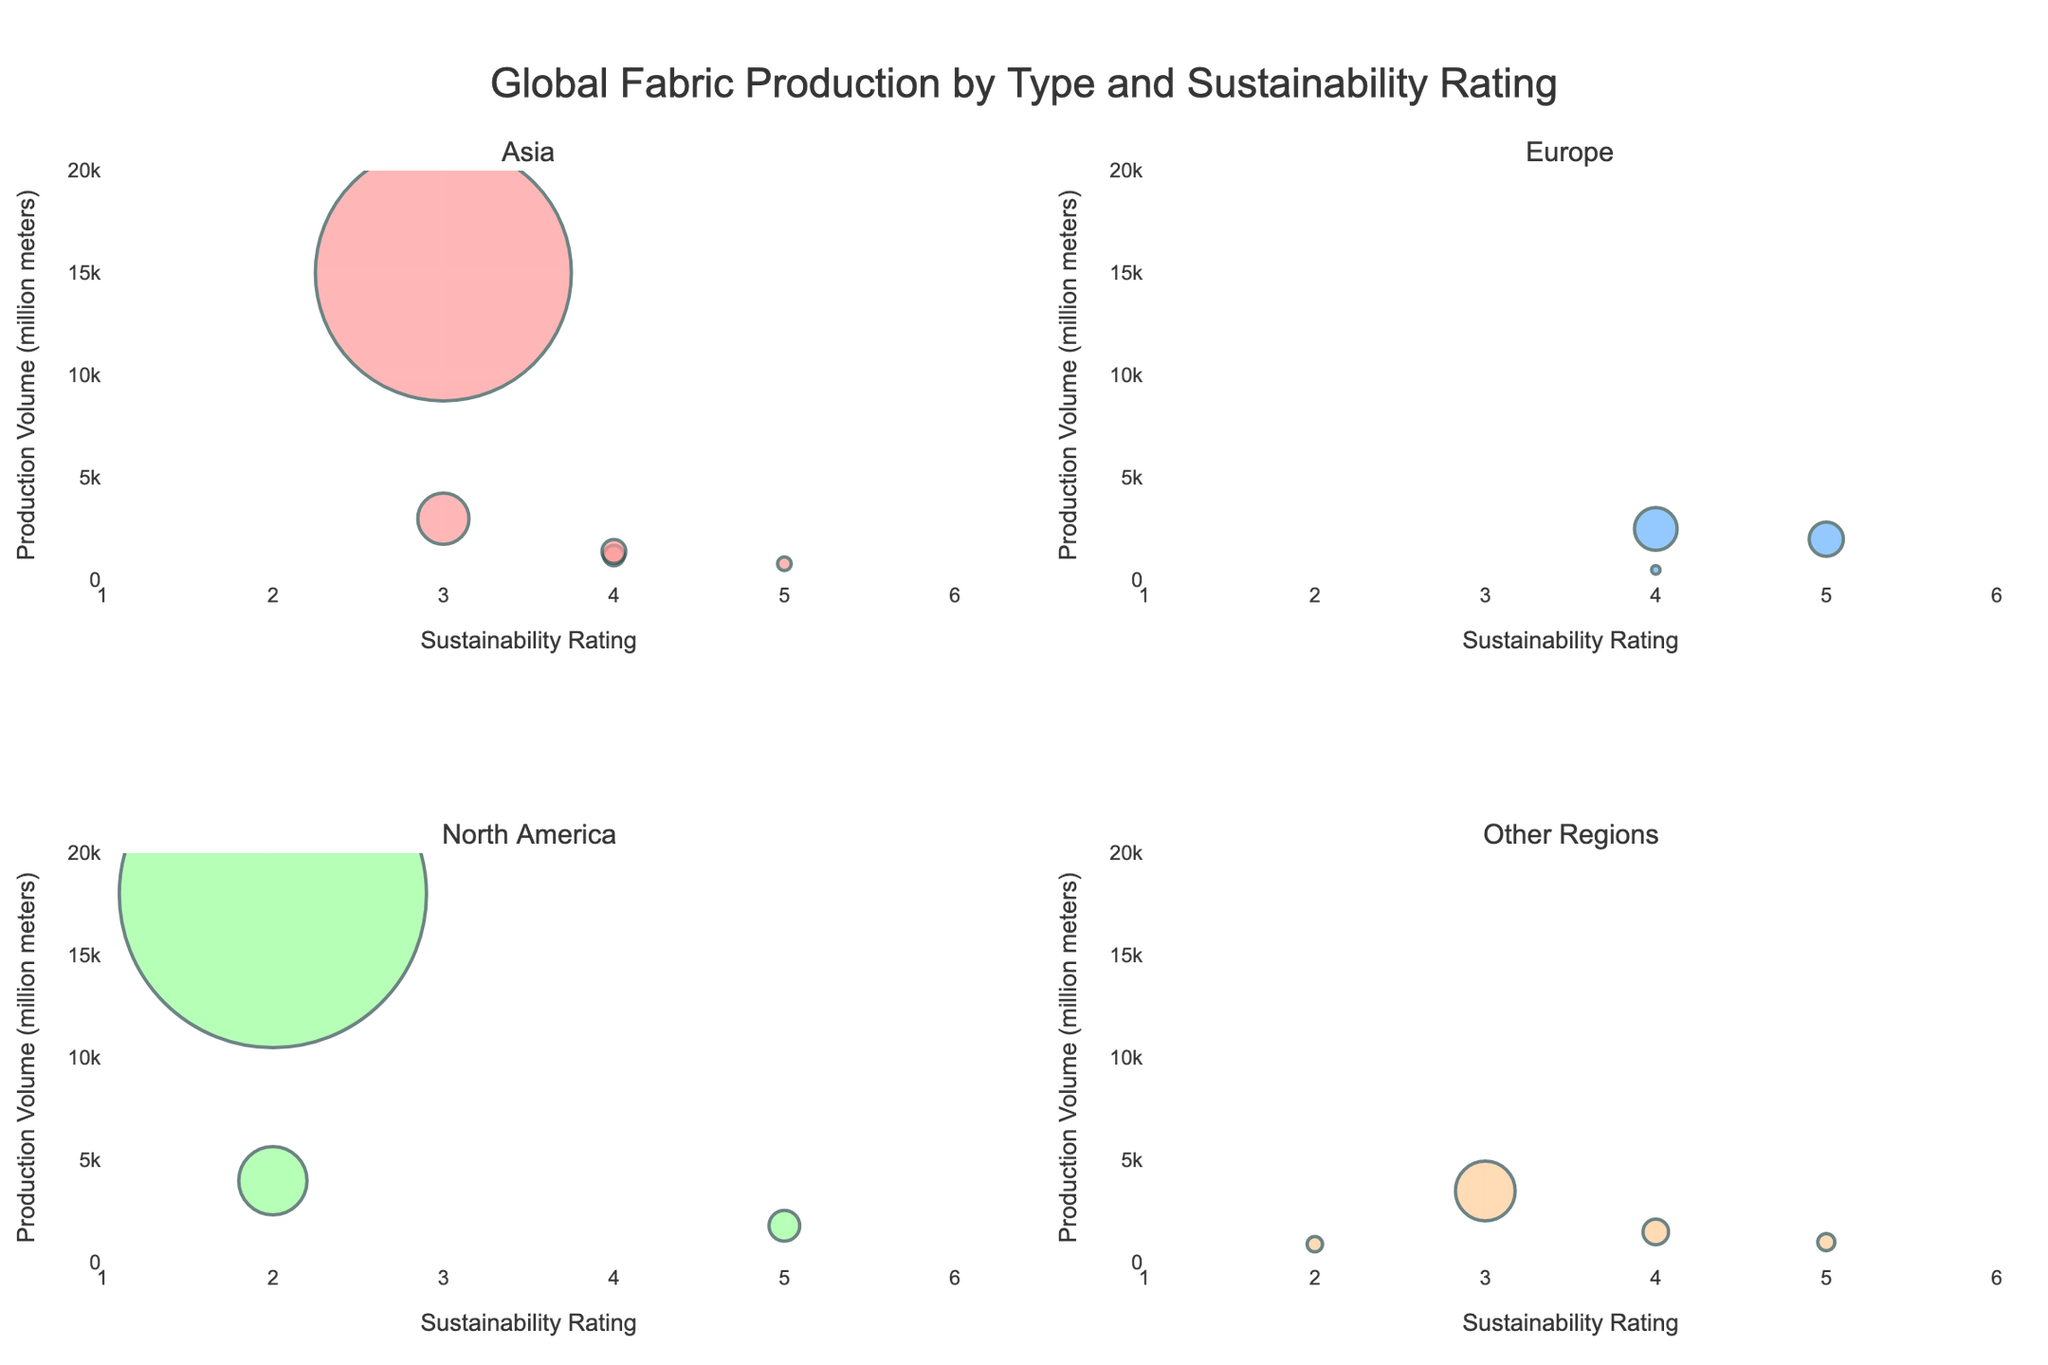What is the sustainability rating range displayed on the x-axes? The x-axes on all subplots have sustainability ratings ranging from 1 to 6 as indicated by the labeled axis and tick marks.
Answer: 1 to 6 How many fabric types have a sustainability rating of 5? By counting the bubbles on all plots positioned at a sustainability rating of 5, we find four fabric types: Linen, Organic Cotton, Tencel, and Hemp.
Answer: Four Which region has the highest production volume for a single fabric type? By examining the y-axes across all subplots, we see that Polyester in North America reaches the highest production volume at 18,000 million meters.
Answer: North America What fabric type in Asia has the highest sustainability rating? By observing the bubbles in the Asia subplot, the fabric type with the highest sustainability rating of 5 is Hemp.
Answer: Hemp Which subplot has the least number of data points representing fabric types? The Europe subplot has the least number of data points, with only three fabric types represented: Silk, Linen, and Recycled Polyester.
Answer: Europe Compare the total production volume of fabrics in North America to those in Asia. Which is greater and by how much? Summing the production volumes in North America (Polyester: 18000 million meters, Nylon: 4000, Tencel: 1800) yields 23800 million meters. Asia (Cotton: 15000, Hemp: 800, Bamboo: 1200, Modal: 1400, Denim: 3000) totals 21400 million meters. North America exceeds Asia by 2400 million meters.
Answer: North America by 2400 million meters Which fabric type has the largest bubble in the Europe subplot, and what does it indicate? The largest bubble in the Europe subplot represents Recycled Polyester, indicating it has the highest production volume of fabrics in this region.
Answer: Recycled Polyester What is the total number of fabric types represented across all regions? Adding the data points from all subplots, we count a total of 15 different fabric types represented.
Answer: Fifteen Are there more fabric types with a sustainability rating of 3 or 4? By counting the relevant bubbles across all subplots, there are four fabric types with a sustainability rating of 3 (Cotton, Viscose, Denim, Leather) and five with a rating of 4 (Silk, Wool, Bamboo, Recycled Polyester, Modal).
Answer: 4 